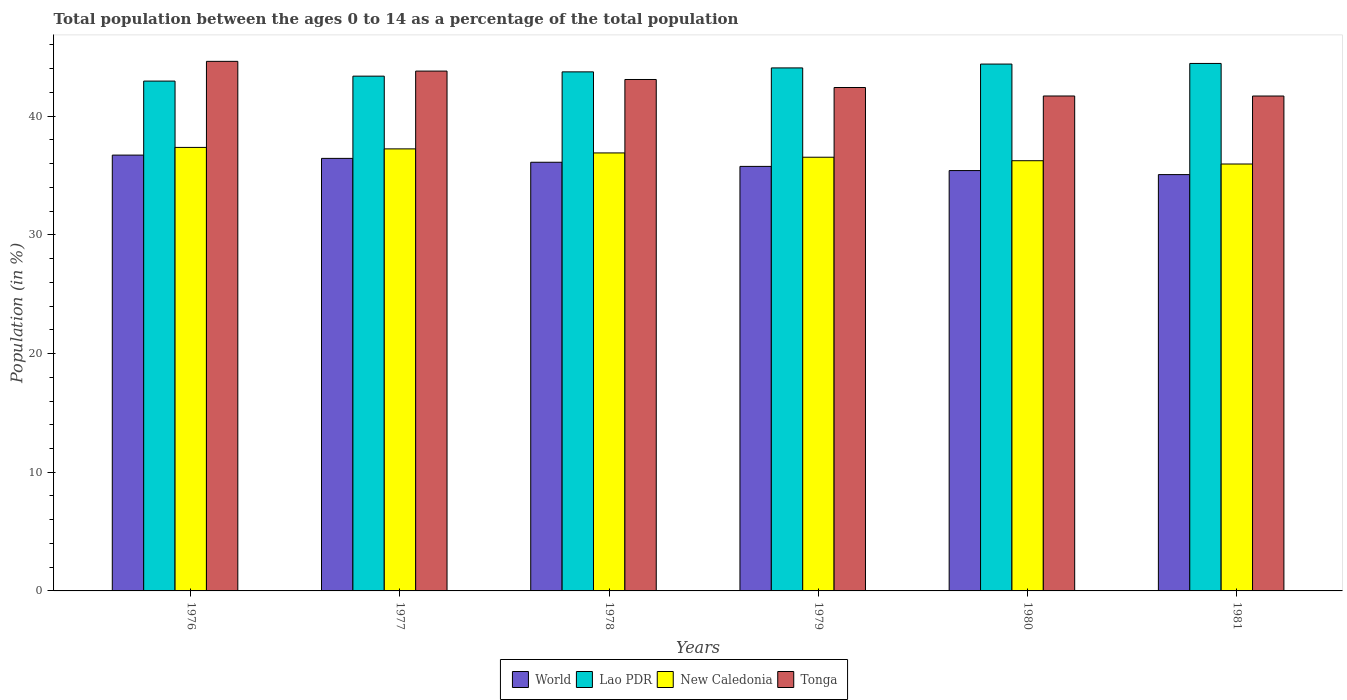How many different coloured bars are there?
Make the answer very short. 4. Are the number of bars on each tick of the X-axis equal?
Give a very brief answer. Yes. How many bars are there on the 4th tick from the left?
Ensure brevity in your answer.  4. How many bars are there on the 4th tick from the right?
Provide a short and direct response. 4. What is the percentage of the population ages 0 to 14 in World in 1976?
Your answer should be compact. 36.72. Across all years, what is the maximum percentage of the population ages 0 to 14 in World?
Your answer should be very brief. 36.72. Across all years, what is the minimum percentage of the population ages 0 to 14 in New Caledonia?
Your response must be concise. 35.97. In which year was the percentage of the population ages 0 to 14 in New Caledonia maximum?
Your answer should be compact. 1976. In which year was the percentage of the population ages 0 to 14 in New Caledonia minimum?
Give a very brief answer. 1981. What is the total percentage of the population ages 0 to 14 in New Caledonia in the graph?
Provide a succinct answer. 220.28. What is the difference between the percentage of the population ages 0 to 14 in Lao PDR in 1978 and that in 1981?
Ensure brevity in your answer.  -0.71. What is the difference between the percentage of the population ages 0 to 14 in Lao PDR in 1981 and the percentage of the population ages 0 to 14 in Tonga in 1978?
Provide a short and direct response. 1.35. What is the average percentage of the population ages 0 to 14 in Lao PDR per year?
Your answer should be compact. 43.83. In the year 1981, what is the difference between the percentage of the population ages 0 to 14 in World and percentage of the population ages 0 to 14 in New Caledonia?
Your answer should be compact. -0.89. In how many years, is the percentage of the population ages 0 to 14 in New Caledonia greater than 8?
Ensure brevity in your answer.  6. What is the ratio of the percentage of the population ages 0 to 14 in New Caledonia in 1978 to that in 1980?
Offer a very short reply. 1.02. Is the percentage of the population ages 0 to 14 in Tonga in 1978 less than that in 1981?
Offer a terse response. No. Is the difference between the percentage of the population ages 0 to 14 in World in 1977 and 1978 greater than the difference between the percentage of the population ages 0 to 14 in New Caledonia in 1977 and 1978?
Your answer should be very brief. No. What is the difference between the highest and the second highest percentage of the population ages 0 to 14 in World?
Offer a very short reply. 0.28. What is the difference between the highest and the lowest percentage of the population ages 0 to 14 in Tonga?
Provide a short and direct response. 2.92. Is the sum of the percentage of the population ages 0 to 14 in Tonga in 1977 and 1979 greater than the maximum percentage of the population ages 0 to 14 in World across all years?
Offer a terse response. Yes. Is it the case that in every year, the sum of the percentage of the population ages 0 to 14 in New Caledonia and percentage of the population ages 0 to 14 in Tonga is greater than the sum of percentage of the population ages 0 to 14 in Lao PDR and percentage of the population ages 0 to 14 in World?
Your answer should be compact. Yes. What does the 3rd bar from the left in 1978 represents?
Your response must be concise. New Caledonia. What does the 3rd bar from the right in 1976 represents?
Make the answer very short. Lao PDR. Is it the case that in every year, the sum of the percentage of the population ages 0 to 14 in World and percentage of the population ages 0 to 14 in New Caledonia is greater than the percentage of the population ages 0 to 14 in Tonga?
Offer a terse response. Yes. How many years are there in the graph?
Provide a short and direct response. 6. What is the difference between two consecutive major ticks on the Y-axis?
Your answer should be very brief. 10. Where does the legend appear in the graph?
Your answer should be very brief. Bottom center. How many legend labels are there?
Your response must be concise. 4. What is the title of the graph?
Provide a short and direct response. Total population between the ages 0 to 14 as a percentage of the total population. Does "Romania" appear as one of the legend labels in the graph?
Offer a very short reply. No. What is the label or title of the X-axis?
Offer a very short reply. Years. What is the label or title of the Y-axis?
Your answer should be very brief. Population (in %). What is the Population (in %) of World in 1976?
Keep it short and to the point. 36.72. What is the Population (in %) of Lao PDR in 1976?
Provide a short and direct response. 42.96. What is the Population (in %) of New Caledonia in 1976?
Offer a very short reply. 37.37. What is the Population (in %) of Tonga in 1976?
Your answer should be compact. 44.62. What is the Population (in %) of World in 1977?
Keep it short and to the point. 36.44. What is the Population (in %) of Lao PDR in 1977?
Give a very brief answer. 43.37. What is the Population (in %) in New Caledonia in 1977?
Provide a succinct answer. 37.25. What is the Population (in %) in Tonga in 1977?
Provide a succinct answer. 43.8. What is the Population (in %) of World in 1978?
Your answer should be very brief. 36.12. What is the Population (in %) of Lao PDR in 1978?
Offer a terse response. 43.73. What is the Population (in %) in New Caledonia in 1978?
Keep it short and to the point. 36.9. What is the Population (in %) in Tonga in 1978?
Provide a short and direct response. 43.09. What is the Population (in %) of World in 1979?
Your answer should be very brief. 35.77. What is the Population (in %) in Lao PDR in 1979?
Your answer should be compact. 44.07. What is the Population (in %) in New Caledonia in 1979?
Give a very brief answer. 36.54. What is the Population (in %) of Tonga in 1979?
Your answer should be compact. 42.42. What is the Population (in %) of World in 1980?
Make the answer very short. 35.42. What is the Population (in %) in Lao PDR in 1980?
Provide a succinct answer. 44.39. What is the Population (in %) in New Caledonia in 1980?
Give a very brief answer. 36.25. What is the Population (in %) in Tonga in 1980?
Give a very brief answer. 41.7. What is the Population (in %) of World in 1981?
Offer a very short reply. 35.08. What is the Population (in %) in Lao PDR in 1981?
Ensure brevity in your answer.  44.44. What is the Population (in %) of New Caledonia in 1981?
Provide a succinct answer. 35.97. What is the Population (in %) in Tonga in 1981?
Your answer should be compact. 41.7. Across all years, what is the maximum Population (in %) of World?
Provide a succinct answer. 36.72. Across all years, what is the maximum Population (in %) in Lao PDR?
Give a very brief answer. 44.44. Across all years, what is the maximum Population (in %) of New Caledonia?
Your answer should be compact. 37.37. Across all years, what is the maximum Population (in %) of Tonga?
Give a very brief answer. 44.62. Across all years, what is the minimum Population (in %) in World?
Make the answer very short. 35.08. Across all years, what is the minimum Population (in %) of Lao PDR?
Make the answer very short. 42.96. Across all years, what is the minimum Population (in %) of New Caledonia?
Provide a succinct answer. 35.97. Across all years, what is the minimum Population (in %) in Tonga?
Give a very brief answer. 41.7. What is the total Population (in %) of World in the graph?
Offer a terse response. 215.55. What is the total Population (in %) in Lao PDR in the graph?
Ensure brevity in your answer.  262.97. What is the total Population (in %) of New Caledonia in the graph?
Give a very brief answer. 220.28. What is the total Population (in %) of Tonga in the graph?
Ensure brevity in your answer.  257.33. What is the difference between the Population (in %) of World in 1976 and that in 1977?
Offer a terse response. 0.28. What is the difference between the Population (in %) of Lao PDR in 1976 and that in 1977?
Provide a succinct answer. -0.42. What is the difference between the Population (in %) of New Caledonia in 1976 and that in 1977?
Keep it short and to the point. 0.12. What is the difference between the Population (in %) of Tonga in 1976 and that in 1977?
Ensure brevity in your answer.  0.82. What is the difference between the Population (in %) of World in 1976 and that in 1978?
Offer a very short reply. 0.6. What is the difference between the Population (in %) in Lao PDR in 1976 and that in 1978?
Your answer should be very brief. -0.78. What is the difference between the Population (in %) of New Caledonia in 1976 and that in 1978?
Your answer should be very brief. 0.46. What is the difference between the Population (in %) of Tonga in 1976 and that in 1978?
Give a very brief answer. 1.53. What is the difference between the Population (in %) in World in 1976 and that in 1979?
Your response must be concise. 0.95. What is the difference between the Population (in %) in Lao PDR in 1976 and that in 1979?
Keep it short and to the point. -1.11. What is the difference between the Population (in %) in New Caledonia in 1976 and that in 1979?
Your response must be concise. 0.83. What is the difference between the Population (in %) in Tonga in 1976 and that in 1979?
Your answer should be compact. 2.2. What is the difference between the Population (in %) in World in 1976 and that in 1980?
Ensure brevity in your answer.  1.3. What is the difference between the Population (in %) in Lao PDR in 1976 and that in 1980?
Your answer should be very brief. -1.43. What is the difference between the Population (in %) in New Caledonia in 1976 and that in 1980?
Your response must be concise. 1.12. What is the difference between the Population (in %) in Tonga in 1976 and that in 1980?
Your answer should be very brief. 2.92. What is the difference between the Population (in %) of World in 1976 and that in 1981?
Provide a short and direct response. 1.64. What is the difference between the Population (in %) of Lao PDR in 1976 and that in 1981?
Keep it short and to the point. -1.49. What is the difference between the Population (in %) in New Caledonia in 1976 and that in 1981?
Make the answer very short. 1.4. What is the difference between the Population (in %) in Tonga in 1976 and that in 1981?
Keep it short and to the point. 2.92. What is the difference between the Population (in %) of World in 1977 and that in 1978?
Make the answer very short. 0.33. What is the difference between the Population (in %) of Lao PDR in 1977 and that in 1978?
Your answer should be very brief. -0.36. What is the difference between the Population (in %) of New Caledonia in 1977 and that in 1978?
Ensure brevity in your answer.  0.34. What is the difference between the Population (in %) in Tonga in 1977 and that in 1978?
Make the answer very short. 0.71. What is the difference between the Population (in %) in World in 1977 and that in 1979?
Your response must be concise. 0.68. What is the difference between the Population (in %) of Lao PDR in 1977 and that in 1979?
Give a very brief answer. -0.69. What is the difference between the Population (in %) of New Caledonia in 1977 and that in 1979?
Your answer should be very brief. 0.7. What is the difference between the Population (in %) in Tonga in 1977 and that in 1979?
Offer a terse response. 1.38. What is the difference between the Population (in %) in World in 1977 and that in 1980?
Your answer should be compact. 1.03. What is the difference between the Population (in %) of Lao PDR in 1977 and that in 1980?
Keep it short and to the point. -1.02. What is the difference between the Population (in %) of Tonga in 1977 and that in 1980?
Make the answer very short. 2.1. What is the difference between the Population (in %) of World in 1977 and that in 1981?
Your answer should be very brief. 1.37. What is the difference between the Population (in %) in Lao PDR in 1977 and that in 1981?
Give a very brief answer. -1.07. What is the difference between the Population (in %) of New Caledonia in 1977 and that in 1981?
Ensure brevity in your answer.  1.27. What is the difference between the Population (in %) in Tonga in 1977 and that in 1981?
Make the answer very short. 2.1. What is the difference between the Population (in %) of World in 1978 and that in 1979?
Your answer should be very brief. 0.35. What is the difference between the Population (in %) in Lao PDR in 1978 and that in 1979?
Keep it short and to the point. -0.33. What is the difference between the Population (in %) of New Caledonia in 1978 and that in 1979?
Offer a terse response. 0.36. What is the difference between the Population (in %) in Tonga in 1978 and that in 1979?
Keep it short and to the point. 0.68. What is the difference between the Population (in %) of World in 1978 and that in 1980?
Keep it short and to the point. 0.7. What is the difference between the Population (in %) in Lao PDR in 1978 and that in 1980?
Make the answer very short. -0.66. What is the difference between the Population (in %) of New Caledonia in 1978 and that in 1980?
Provide a succinct answer. 0.66. What is the difference between the Population (in %) in Tonga in 1978 and that in 1980?
Offer a very short reply. 1.39. What is the difference between the Population (in %) of World in 1978 and that in 1981?
Provide a succinct answer. 1.04. What is the difference between the Population (in %) in Lao PDR in 1978 and that in 1981?
Offer a terse response. -0.71. What is the difference between the Population (in %) of New Caledonia in 1978 and that in 1981?
Your answer should be compact. 0.93. What is the difference between the Population (in %) of Tonga in 1978 and that in 1981?
Your answer should be compact. 1.39. What is the difference between the Population (in %) in World in 1979 and that in 1980?
Make the answer very short. 0.35. What is the difference between the Population (in %) in Lao PDR in 1979 and that in 1980?
Keep it short and to the point. -0.32. What is the difference between the Population (in %) in New Caledonia in 1979 and that in 1980?
Provide a succinct answer. 0.29. What is the difference between the Population (in %) of Tonga in 1979 and that in 1980?
Make the answer very short. 0.72. What is the difference between the Population (in %) in World in 1979 and that in 1981?
Your answer should be very brief. 0.69. What is the difference between the Population (in %) in Lao PDR in 1979 and that in 1981?
Provide a short and direct response. -0.38. What is the difference between the Population (in %) in New Caledonia in 1979 and that in 1981?
Provide a succinct answer. 0.57. What is the difference between the Population (in %) of Tonga in 1979 and that in 1981?
Provide a succinct answer. 0.72. What is the difference between the Population (in %) of World in 1980 and that in 1981?
Offer a very short reply. 0.34. What is the difference between the Population (in %) in Lao PDR in 1980 and that in 1981?
Ensure brevity in your answer.  -0.05. What is the difference between the Population (in %) in New Caledonia in 1980 and that in 1981?
Provide a short and direct response. 0.28. What is the difference between the Population (in %) in Tonga in 1980 and that in 1981?
Provide a short and direct response. 0. What is the difference between the Population (in %) of World in 1976 and the Population (in %) of Lao PDR in 1977?
Provide a short and direct response. -6.65. What is the difference between the Population (in %) in World in 1976 and the Population (in %) in New Caledonia in 1977?
Make the answer very short. -0.52. What is the difference between the Population (in %) of World in 1976 and the Population (in %) of Tonga in 1977?
Offer a very short reply. -7.08. What is the difference between the Population (in %) in Lao PDR in 1976 and the Population (in %) in New Caledonia in 1977?
Offer a very short reply. 5.71. What is the difference between the Population (in %) in Lao PDR in 1976 and the Population (in %) in Tonga in 1977?
Provide a short and direct response. -0.84. What is the difference between the Population (in %) of New Caledonia in 1976 and the Population (in %) of Tonga in 1977?
Your response must be concise. -6.43. What is the difference between the Population (in %) in World in 1976 and the Population (in %) in Lao PDR in 1978?
Make the answer very short. -7.01. What is the difference between the Population (in %) of World in 1976 and the Population (in %) of New Caledonia in 1978?
Ensure brevity in your answer.  -0.18. What is the difference between the Population (in %) of World in 1976 and the Population (in %) of Tonga in 1978?
Make the answer very short. -6.37. What is the difference between the Population (in %) of Lao PDR in 1976 and the Population (in %) of New Caledonia in 1978?
Your answer should be very brief. 6.05. What is the difference between the Population (in %) in Lao PDR in 1976 and the Population (in %) in Tonga in 1978?
Provide a short and direct response. -0.14. What is the difference between the Population (in %) of New Caledonia in 1976 and the Population (in %) of Tonga in 1978?
Your response must be concise. -5.72. What is the difference between the Population (in %) in World in 1976 and the Population (in %) in Lao PDR in 1979?
Give a very brief answer. -7.35. What is the difference between the Population (in %) of World in 1976 and the Population (in %) of New Caledonia in 1979?
Your answer should be very brief. 0.18. What is the difference between the Population (in %) of World in 1976 and the Population (in %) of Tonga in 1979?
Offer a terse response. -5.7. What is the difference between the Population (in %) of Lao PDR in 1976 and the Population (in %) of New Caledonia in 1979?
Your response must be concise. 6.41. What is the difference between the Population (in %) in Lao PDR in 1976 and the Population (in %) in Tonga in 1979?
Offer a terse response. 0.54. What is the difference between the Population (in %) of New Caledonia in 1976 and the Population (in %) of Tonga in 1979?
Provide a succinct answer. -5.05. What is the difference between the Population (in %) of World in 1976 and the Population (in %) of Lao PDR in 1980?
Give a very brief answer. -7.67. What is the difference between the Population (in %) of World in 1976 and the Population (in %) of New Caledonia in 1980?
Keep it short and to the point. 0.47. What is the difference between the Population (in %) of World in 1976 and the Population (in %) of Tonga in 1980?
Your answer should be compact. -4.98. What is the difference between the Population (in %) in Lao PDR in 1976 and the Population (in %) in New Caledonia in 1980?
Ensure brevity in your answer.  6.71. What is the difference between the Population (in %) of Lao PDR in 1976 and the Population (in %) of Tonga in 1980?
Provide a short and direct response. 1.26. What is the difference between the Population (in %) of New Caledonia in 1976 and the Population (in %) of Tonga in 1980?
Your answer should be compact. -4.33. What is the difference between the Population (in %) of World in 1976 and the Population (in %) of Lao PDR in 1981?
Offer a very short reply. -7.72. What is the difference between the Population (in %) of World in 1976 and the Population (in %) of New Caledonia in 1981?
Your response must be concise. 0.75. What is the difference between the Population (in %) of World in 1976 and the Population (in %) of Tonga in 1981?
Make the answer very short. -4.98. What is the difference between the Population (in %) of Lao PDR in 1976 and the Population (in %) of New Caledonia in 1981?
Your response must be concise. 6.99. What is the difference between the Population (in %) of Lao PDR in 1976 and the Population (in %) of Tonga in 1981?
Ensure brevity in your answer.  1.26. What is the difference between the Population (in %) in New Caledonia in 1976 and the Population (in %) in Tonga in 1981?
Provide a succinct answer. -4.33. What is the difference between the Population (in %) in World in 1977 and the Population (in %) in Lao PDR in 1978?
Keep it short and to the point. -7.29. What is the difference between the Population (in %) in World in 1977 and the Population (in %) in New Caledonia in 1978?
Provide a short and direct response. -0.46. What is the difference between the Population (in %) in World in 1977 and the Population (in %) in Tonga in 1978?
Provide a succinct answer. -6.65. What is the difference between the Population (in %) of Lao PDR in 1977 and the Population (in %) of New Caledonia in 1978?
Ensure brevity in your answer.  6.47. What is the difference between the Population (in %) in Lao PDR in 1977 and the Population (in %) in Tonga in 1978?
Your answer should be very brief. 0.28. What is the difference between the Population (in %) in New Caledonia in 1977 and the Population (in %) in Tonga in 1978?
Ensure brevity in your answer.  -5.85. What is the difference between the Population (in %) in World in 1977 and the Population (in %) in Lao PDR in 1979?
Provide a short and direct response. -7.62. What is the difference between the Population (in %) in World in 1977 and the Population (in %) in New Caledonia in 1979?
Ensure brevity in your answer.  -0.1. What is the difference between the Population (in %) of World in 1977 and the Population (in %) of Tonga in 1979?
Offer a terse response. -5.97. What is the difference between the Population (in %) of Lao PDR in 1977 and the Population (in %) of New Caledonia in 1979?
Make the answer very short. 6.83. What is the difference between the Population (in %) in Lao PDR in 1977 and the Population (in %) in Tonga in 1979?
Offer a terse response. 0.96. What is the difference between the Population (in %) in New Caledonia in 1977 and the Population (in %) in Tonga in 1979?
Give a very brief answer. -5.17. What is the difference between the Population (in %) in World in 1977 and the Population (in %) in Lao PDR in 1980?
Offer a terse response. -7.95. What is the difference between the Population (in %) in World in 1977 and the Population (in %) in New Caledonia in 1980?
Provide a short and direct response. 0.2. What is the difference between the Population (in %) in World in 1977 and the Population (in %) in Tonga in 1980?
Offer a terse response. -5.26. What is the difference between the Population (in %) in Lao PDR in 1977 and the Population (in %) in New Caledonia in 1980?
Your answer should be compact. 7.13. What is the difference between the Population (in %) in Lao PDR in 1977 and the Population (in %) in Tonga in 1980?
Give a very brief answer. 1.67. What is the difference between the Population (in %) in New Caledonia in 1977 and the Population (in %) in Tonga in 1980?
Give a very brief answer. -4.46. What is the difference between the Population (in %) of World in 1977 and the Population (in %) of Lao PDR in 1981?
Make the answer very short. -8. What is the difference between the Population (in %) of World in 1977 and the Population (in %) of New Caledonia in 1981?
Ensure brevity in your answer.  0.47. What is the difference between the Population (in %) in World in 1977 and the Population (in %) in Tonga in 1981?
Offer a terse response. -5.26. What is the difference between the Population (in %) of Lao PDR in 1977 and the Population (in %) of New Caledonia in 1981?
Your answer should be very brief. 7.4. What is the difference between the Population (in %) of Lao PDR in 1977 and the Population (in %) of Tonga in 1981?
Provide a short and direct response. 1.67. What is the difference between the Population (in %) in New Caledonia in 1977 and the Population (in %) in Tonga in 1981?
Ensure brevity in your answer.  -4.45. What is the difference between the Population (in %) in World in 1978 and the Population (in %) in Lao PDR in 1979?
Make the answer very short. -7.95. What is the difference between the Population (in %) of World in 1978 and the Population (in %) of New Caledonia in 1979?
Offer a very short reply. -0.42. What is the difference between the Population (in %) of World in 1978 and the Population (in %) of Tonga in 1979?
Keep it short and to the point. -6.3. What is the difference between the Population (in %) of Lao PDR in 1978 and the Population (in %) of New Caledonia in 1979?
Offer a very short reply. 7.19. What is the difference between the Population (in %) in Lao PDR in 1978 and the Population (in %) in Tonga in 1979?
Your answer should be compact. 1.32. What is the difference between the Population (in %) of New Caledonia in 1978 and the Population (in %) of Tonga in 1979?
Provide a succinct answer. -5.51. What is the difference between the Population (in %) in World in 1978 and the Population (in %) in Lao PDR in 1980?
Give a very brief answer. -8.27. What is the difference between the Population (in %) in World in 1978 and the Population (in %) in New Caledonia in 1980?
Your answer should be very brief. -0.13. What is the difference between the Population (in %) of World in 1978 and the Population (in %) of Tonga in 1980?
Ensure brevity in your answer.  -5.58. What is the difference between the Population (in %) in Lao PDR in 1978 and the Population (in %) in New Caledonia in 1980?
Your answer should be very brief. 7.49. What is the difference between the Population (in %) in Lao PDR in 1978 and the Population (in %) in Tonga in 1980?
Provide a short and direct response. 2.03. What is the difference between the Population (in %) of New Caledonia in 1978 and the Population (in %) of Tonga in 1980?
Provide a succinct answer. -4.8. What is the difference between the Population (in %) in World in 1978 and the Population (in %) in Lao PDR in 1981?
Your answer should be very brief. -8.33. What is the difference between the Population (in %) of World in 1978 and the Population (in %) of New Caledonia in 1981?
Offer a terse response. 0.15. What is the difference between the Population (in %) of World in 1978 and the Population (in %) of Tonga in 1981?
Give a very brief answer. -5.58. What is the difference between the Population (in %) in Lao PDR in 1978 and the Population (in %) in New Caledonia in 1981?
Provide a short and direct response. 7.76. What is the difference between the Population (in %) of Lao PDR in 1978 and the Population (in %) of Tonga in 1981?
Offer a very short reply. 2.03. What is the difference between the Population (in %) in New Caledonia in 1978 and the Population (in %) in Tonga in 1981?
Your answer should be compact. -4.8. What is the difference between the Population (in %) in World in 1979 and the Population (in %) in Lao PDR in 1980?
Provide a short and direct response. -8.62. What is the difference between the Population (in %) of World in 1979 and the Population (in %) of New Caledonia in 1980?
Offer a very short reply. -0.48. What is the difference between the Population (in %) in World in 1979 and the Population (in %) in Tonga in 1980?
Your response must be concise. -5.93. What is the difference between the Population (in %) of Lao PDR in 1979 and the Population (in %) of New Caledonia in 1980?
Your answer should be compact. 7.82. What is the difference between the Population (in %) in Lao PDR in 1979 and the Population (in %) in Tonga in 1980?
Provide a short and direct response. 2.37. What is the difference between the Population (in %) of New Caledonia in 1979 and the Population (in %) of Tonga in 1980?
Your answer should be very brief. -5.16. What is the difference between the Population (in %) in World in 1979 and the Population (in %) in Lao PDR in 1981?
Your answer should be compact. -8.67. What is the difference between the Population (in %) in World in 1979 and the Population (in %) in New Caledonia in 1981?
Offer a very short reply. -0.2. What is the difference between the Population (in %) of World in 1979 and the Population (in %) of Tonga in 1981?
Ensure brevity in your answer.  -5.93. What is the difference between the Population (in %) in Lao PDR in 1979 and the Population (in %) in New Caledonia in 1981?
Make the answer very short. 8.1. What is the difference between the Population (in %) in Lao PDR in 1979 and the Population (in %) in Tonga in 1981?
Offer a very short reply. 2.37. What is the difference between the Population (in %) of New Caledonia in 1979 and the Population (in %) of Tonga in 1981?
Offer a very short reply. -5.16. What is the difference between the Population (in %) in World in 1980 and the Population (in %) in Lao PDR in 1981?
Provide a short and direct response. -9.03. What is the difference between the Population (in %) in World in 1980 and the Population (in %) in New Caledonia in 1981?
Keep it short and to the point. -0.55. What is the difference between the Population (in %) in World in 1980 and the Population (in %) in Tonga in 1981?
Keep it short and to the point. -6.28. What is the difference between the Population (in %) in Lao PDR in 1980 and the Population (in %) in New Caledonia in 1981?
Make the answer very short. 8.42. What is the difference between the Population (in %) in Lao PDR in 1980 and the Population (in %) in Tonga in 1981?
Your answer should be very brief. 2.69. What is the difference between the Population (in %) of New Caledonia in 1980 and the Population (in %) of Tonga in 1981?
Give a very brief answer. -5.45. What is the average Population (in %) of World per year?
Offer a terse response. 35.92. What is the average Population (in %) in Lao PDR per year?
Provide a short and direct response. 43.83. What is the average Population (in %) of New Caledonia per year?
Make the answer very short. 36.71. What is the average Population (in %) in Tonga per year?
Your answer should be very brief. 42.89. In the year 1976, what is the difference between the Population (in %) of World and Population (in %) of Lao PDR?
Your answer should be compact. -6.24. In the year 1976, what is the difference between the Population (in %) of World and Population (in %) of New Caledonia?
Provide a succinct answer. -0.65. In the year 1976, what is the difference between the Population (in %) in World and Population (in %) in Tonga?
Ensure brevity in your answer.  -7.9. In the year 1976, what is the difference between the Population (in %) in Lao PDR and Population (in %) in New Caledonia?
Offer a terse response. 5.59. In the year 1976, what is the difference between the Population (in %) in Lao PDR and Population (in %) in Tonga?
Ensure brevity in your answer.  -1.66. In the year 1976, what is the difference between the Population (in %) of New Caledonia and Population (in %) of Tonga?
Offer a terse response. -7.25. In the year 1977, what is the difference between the Population (in %) of World and Population (in %) of Lao PDR?
Provide a short and direct response. -6.93. In the year 1977, what is the difference between the Population (in %) in World and Population (in %) in New Caledonia?
Give a very brief answer. -0.8. In the year 1977, what is the difference between the Population (in %) in World and Population (in %) in Tonga?
Make the answer very short. -7.36. In the year 1977, what is the difference between the Population (in %) of Lao PDR and Population (in %) of New Caledonia?
Offer a very short reply. 6.13. In the year 1977, what is the difference between the Population (in %) in Lao PDR and Population (in %) in Tonga?
Offer a terse response. -0.43. In the year 1977, what is the difference between the Population (in %) of New Caledonia and Population (in %) of Tonga?
Offer a terse response. -6.56. In the year 1978, what is the difference between the Population (in %) of World and Population (in %) of Lao PDR?
Provide a short and direct response. -7.62. In the year 1978, what is the difference between the Population (in %) of World and Population (in %) of New Caledonia?
Make the answer very short. -0.79. In the year 1978, what is the difference between the Population (in %) of World and Population (in %) of Tonga?
Make the answer very short. -6.97. In the year 1978, what is the difference between the Population (in %) of Lao PDR and Population (in %) of New Caledonia?
Offer a very short reply. 6.83. In the year 1978, what is the difference between the Population (in %) of Lao PDR and Population (in %) of Tonga?
Ensure brevity in your answer.  0.64. In the year 1978, what is the difference between the Population (in %) in New Caledonia and Population (in %) in Tonga?
Your answer should be compact. -6.19. In the year 1979, what is the difference between the Population (in %) in World and Population (in %) in Lao PDR?
Offer a very short reply. -8.3. In the year 1979, what is the difference between the Population (in %) of World and Population (in %) of New Caledonia?
Provide a short and direct response. -0.77. In the year 1979, what is the difference between the Population (in %) in World and Population (in %) in Tonga?
Provide a succinct answer. -6.65. In the year 1979, what is the difference between the Population (in %) in Lao PDR and Population (in %) in New Caledonia?
Your answer should be compact. 7.52. In the year 1979, what is the difference between the Population (in %) of Lao PDR and Population (in %) of Tonga?
Provide a short and direct response. 1.65. In the year 1979, what is the difference between the Population (in %) in New Caledonia and Population (in %) in Tonga?
Provide a short and direct response. -5.87. In the year 1980, what is the difference between the Population (in %) in World and Population (in %) in Lao PDR?
Offer a very short reply. -8.97. In the year 1980, what is the difference between the Population (in %) in World and Population (in %) in New Caledonia?
Make the answer very short. -0.83. In the year 1980, what is the difference between the Population (in %) of World and Population (in %) of Tonga?
Your answer should be very brief. -6.28. In the year 1980, what is the difference between the Population (in %) of Lao PDR and Population (in %) of New Caledonia?
Your answer should be compact. 8.14. In the year 1980, what is the difference between the Population (in %) in Lao PDR and Population (in %) in Tonga?
Provide a short and direct response. 2.69. In the year 1980, what is the difference between the Population (in %) in New Caledonia and Population (in %) in Tonga?
Make the answer very short. -5.45. In the year 1981, what is the difference between the Population (in %) of World and Population (in %) of Lao PDR?
Keep it short and to the point. -9.36. In the year 1981, what is the difference between the Population (in %) in World and Population (in %) in New Caledonia?
Make the answer very short. -0.89. In the year 1981, what is the difference between the Population (in %) in World and Population (in %) in Tonga?
Keep it short and to the point. -6.62. In the year 1981, what is the difference between the Population (in %) in Lao PDR and Population (in %) in New Caledonia?
Make the answer very short. 8.47. In the year 1981, what is the difference between the Population (in %) of Lao PDR and Population (in %) of Tonga?
Give a very brief answer. 2.74. In the year 1981, what is the difference between the Population (in %) in New Caledonia and Population (in %) in Tonga?
Your answer should be very brief. -5.73. What is the ratio of the Population (in %) in World in 1976 to that in 1977?
Your answer should be very brief. 1.01. What is the ratio of the Population (in %) of Tonga in 1976 to that in 1977?
Your answer should be compact. 1.02. What is the ratio of the Population (in %) of World in 1976 to that in 1978?
Your answer should be compact. 1.02. What is the ratio of the Population (in %) in Lao PDR in 1976 to that in 1978?
Give a very brief answer. 0.98. What is the ratio of the Population (in %) of New Caledonia in 1976 to that in 1978?
Provide a short and direct response. 1.01. What is the ratio of the Population (in %) in Tonga in 1976 to that in 1978?
Your answer should be compact. 1.04. What is the ratio of the Population (in %) of World in 1976 to that in 1979?
Make the answer very short. 1.03. What is the ratio of the Population (in %) of Lao PDR in 1976 to that in 1979?
Offer a terse response. 0.97. What is the ratio of the Population (in %) of New Caledonia in 1976 to that in 1979?
Your answer should be compact. 1.02. What is the ratio of the Population (in %) in Tonga in 1976 to that in 1979?
Provide a succinct answer. 1.05. What is the ratio of the Population (in %) in World in 1976 to that in 1980?
Provide a short and direct response. 1.04. What is the ratio of the Population (in %) in Lao PDR in 1976 to that in 1980?
Your response must be concise. 0.97. What is the ratio of the Population (in %) in New Caledonia in 1976 to that in 1980?
Keep it short and to the point. 1.03. What is the ratio of the Population (in %) of Tonga in 1976 to that in 1980?
Provide a succinct answer. 1.07. What is the ratio of the Population (in %) in World in 1976 to that in 1981?
Your answer should be compact. 1.05. What is the ratio of the Population (in %) in Lao PDR in 1976 to that in 1981?
Provide a short and direct response. 0.97. What is the ratio of the Population (in %) in New Caledonia in 1976 to that in 1981?
Make the answer very short. 1.04. What is the ratio of the Population (in %) of Tonga in 1976 to that in 1981?
Provide a succinct answer. 1.07. What is the ratio of the Population (in %) in World in 1977 to that in 1978?
Your response must be concise. 1.01. What is the ratio of the Population (in %) in New Caledonia in 1977 to that in 1978?
Make the answer very short. 1.01. What is the ratio of the Population (in %) of Tonga in 1977 to that in 1978?
Offer a very short reply. 1.02. What is the ratio of the Population (in %) of World in 1977 to that in 1979?
Your response must be concise. 1.02. What is the ratio of the Population (in %) of Lao PDR in 1977 to that in 1979?
Ensure brevity in your answer.  0.98. What is the ratio of the Population (in %) of New Caledonia in 1977 to that in 1979?
Provide a succinct answer. 1.02. What is the ratio of the Population (in %) in Tonga in 1977 to that in 1979?
Make the answer very short. 1.03. What is the ratio of the Population (in %) in Lao PDR in 1977 to that in 1980?
Ensure brevity in your answer.  0.98. What is the ratio of the Population (in %) in New Caledonia in 1977 to that in 1980?
Give a very brief answer. 1.03. What is the ratio of the Population (in %) in Tonga in 1977 to that in 1980?
Offer a very short reply. 1.05. What is the ratio of the Population (in %) of World in 1977 to that in 1981?
Make the answer very short. 1.04. What is the ratio of the Population (in %) in Lao PDR in 1977 to that in 1981?
Give a very brief answer. 0.98. What is the ratio of the Population (in %) in New Caledonia in 1977 to that in 1981?
Provide a succinct answer. 1.04. What is the ratio of the Population (in %) in Tonga in 1977 to that in 1981?
Provide a short and direct response. 1.05. What is the ratio of the Population (in %) of World in 1978 to that in 1979?
Ensure brevity in your answer.  1.01. What is the ratio of the Population (in %) in Lao PDR in 1978 to that in 1979?
Your answer should be compact. 0.99. What is the ratio of the Population (in %) of New Caledonia in 1978 to that in 1979?
Offer a terse response. 1.01. What is the ratio of the Population (in %) of Tonga in 1978 to that in 1979?
Provide a succinct answer. 1.02. What is the ratio of the Population (in %) of World in 1978 to that in 1980?
Offer a very short reply. 1.02. What is the ratio of the Population (in %) of Lao PDR in 1978 to that in 1980?
Make the answer very short. 0.99. What is the ratio of the Population (in %) of New Caledonia in 1978 to that in 1980?
Your answer should be very brief. 1.02. What is the ratio of the Population (in %) of Tonga in 1978 to that in 1980?
Provide a short and direct response. 1.03. What is the ratio of the Population (in %) of World in 1978 to that in 1981?
Offer a very short reply. 1.03. What is the ratio of the Population (in %) of Lao PDR in 1978 to that in 1981?
Offer a terse response. 0.98. What is the ratio of the Population (in %) of New Caledonia in 1978 to that in 1981?
Offer a very short reply. 1.03. What is the ratio of the Population (in %) in Tonga in 1978 to that in 1981?
Provide a succinct answer. 1.03. What is the ratio of the Population (in %) of World in 1979 to that in 1980?
Your answer should be very brief. 1.01. What is the ratio of the Population (in %) of Tonga in 1979 to that in 1980?
Provide a succinct answer. 1.02. What is the ratio of the Population (in %) in World in 1979 to that in 1981?
Give a very brief answer. 1.02. What is the ratio of the Population (in %) of Lao PDR in 1979 to that in 1981?
Your answer should be compact. 0.99. What is the ratio of the Population (in %) in New Caledonia in 1979 to that in 1981?
Your answer should be compact. 1.02. What is the ratio of the Population (in %) in Tonga in 1979 to that in 1981?
Offer a very short reply. 1.02. What is the ratio of the Population (in %) of World in 1980 to that in 1981?
Offer a terse response. 1.01. What is the ratio of the Population (in %) of New Caledonia in 1980 to that in 1981?
Your response must be concise. 1.01. What is the ratio of the Population (in %) of Tonga in 1980 to that in 1981?
Your answer should be very brief. 1. What is the difference between the highest and the second highest Population (in %) in World?
Provide a succinct answer. 0.28. What is the difference between the highest and the second highest Population (in %) of Lao PDR?
Make the answer very short. 0.05. What is the difference between the highest and the second highest Population (in %) in New Caledonia?
Your response must be concise. 0.12. What is the difference between the highest and the second highest Population (in %) in Tonga?
Provide a succinct answer. 0.82. What is the difference between the highest and the lowest Population (in %) in World?
Your answer should be compact. 1.64. What is the difference between the highest and the lowest Population (in %) of Lao PDR?
Your answer should be very brief. 1.49. What is the difference between the highest and the lowest Population (in %) of New Caledonia?
Make the answer very short. 1.4. What is the difference between the highest and the lowest Population (in %) of Tonga?
Keep it short and to the point. 2.92. 